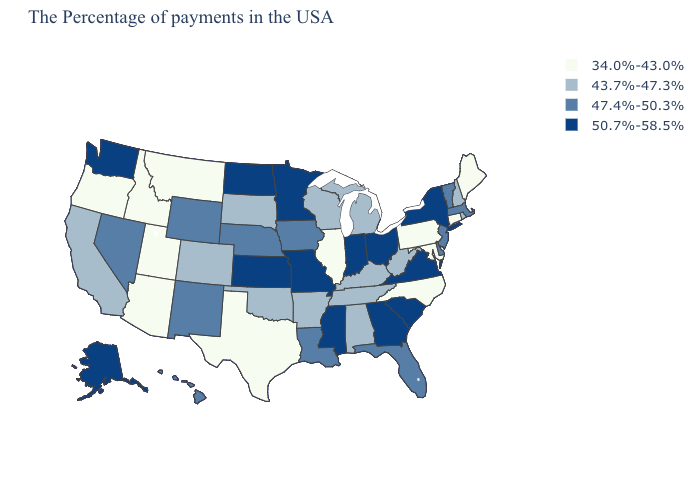Name the states that have a value in the range 50.7%-58.5%?
Give a very brief answer. New York, Virginia, South Carolina, Ohio, Georgia, Indiana, Mississippi, Missouri, Minnesota, Kansas, North Dakota, Washington, Alaska. What is the highest value in the USA?
Concise answer only. 50.7%-58.5%. Does Idaho have the lowest value in the West?
Keep it brief. Yes. What is the value of North Carolina?
Give a very brief answer. 34.0%-43.0%. Name the states that have a value in the range 47.4%-50.3%?
Answer briefly. Massachusetts, Vermont, New Jersey, Delaware, Florida, Louisiana, Iowa, Nebraska, Wyoming, New Mexico, Nevada, Hawaii. What is the lowest value in the USA?
Short answer required. 34.0%-43.0%. Among the states that border Missouri , which have the highest value?
Answer briefly. Kansas. What is the highest value in the South ?
Short answer required. 50.7%-58.5%. What is the value of South Dakota?
Concise answer only. 43.7%-47.3%. Does the first symbol in the legend represent the smallest category?
Give a very brief answer. Yes. Among the states that border South Carolina , does Georgia have the highest value?
Answer briefly. Yes. Name the states that have a value in the range 50.7%-58.5%?
Write a very short answer. New York, Virginia, South Carolina, Ohio, Georgia, Indiana, Mississippi, Missouri, Minnesota, Kansas, North Dakota, Washington, Alaska. Name the states that have a value in the range 47.4%-50.3%?
Write a very short answer. Massachusetts, Vermont, New Jersey, Delaware, Florida, Louisiana, Iowa, Nebraska, Wyoming, New Mexico, Nevada, Hawaii. Does the first symbol in the legend represent the smallest category?
Short answer required. Yes. Does the first symbol in the legend represent the smallest category?
Concise answer only. Yes. 